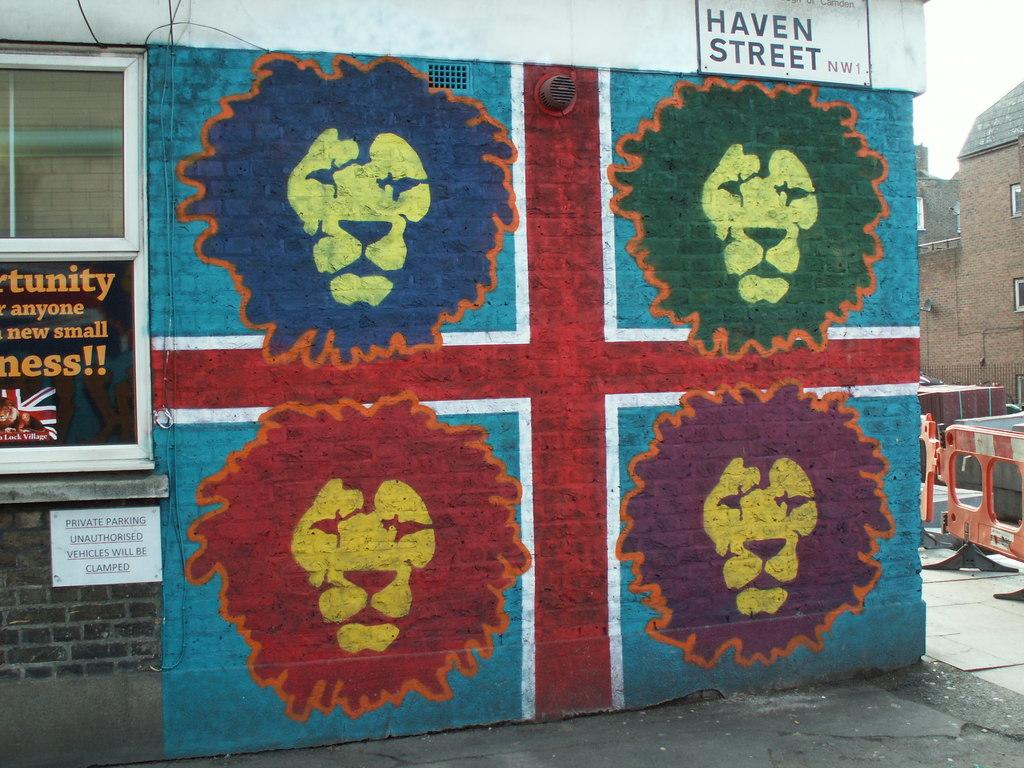What street is this on?
Offer a terse response. Haven. 